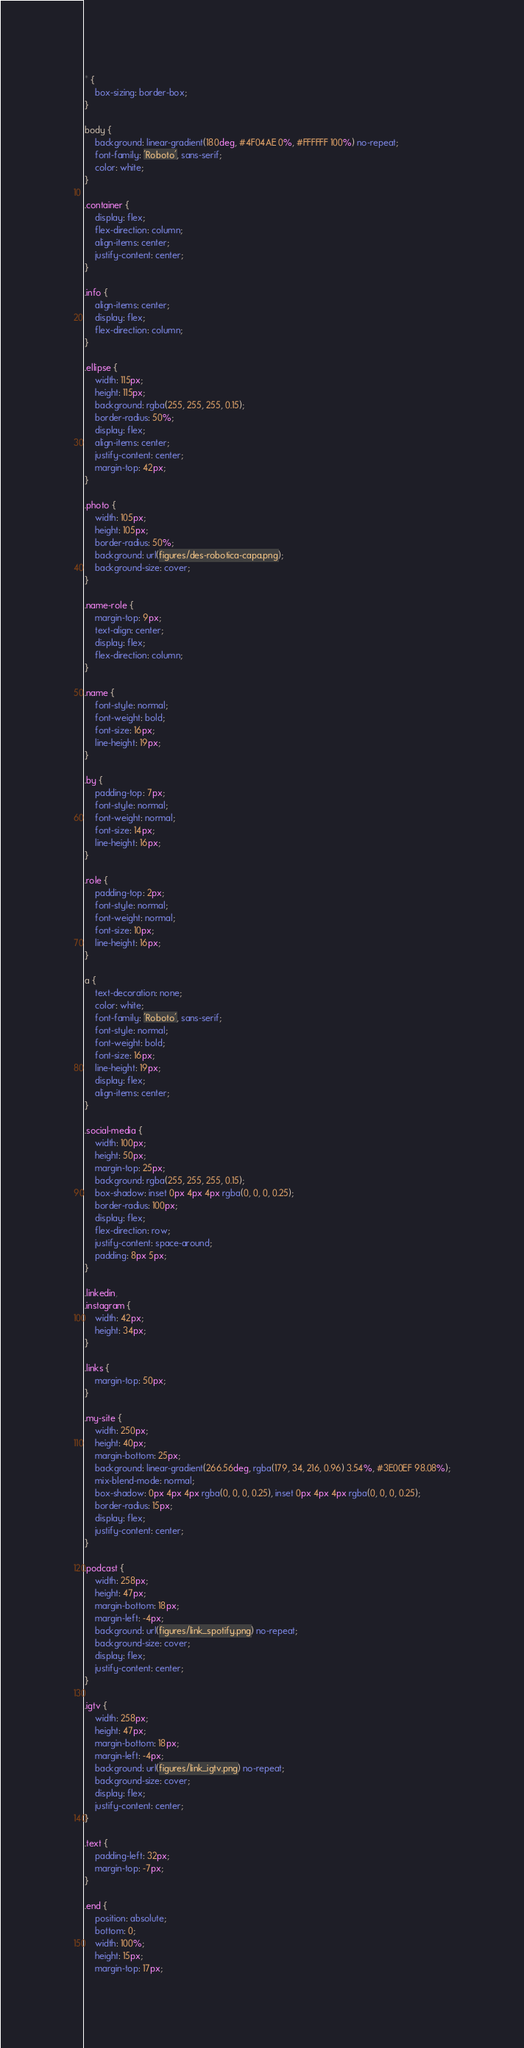<code> <loc_0><loc_0><loc_500><loc_500><_CSS_>* {
    box-sizing: border-box;
}

body {
    background: linear-gradient(180deg, #4F04AE 0%, #FFFFFF 100%) no-repeat;
    font-family: 'Roboto', sans-serif;
    color: white;
}

.container {
    display: flex;
    flex-direction: column;
    align-items: center;
    justify-content: center;
}

.info {
    align-items: center;
    display: flex;
    flex-direction: column;
}

.ellipse {
    width: 115px;
    height: 115px;
    background: rgba(255, 255, 255, 0.15);
    border-radius: 50%;
    display: flex;
    align-items: center;
    justify-content: center;
    margin-top: 42px;
}

.photo {
    width: 105px;
    height: 105px;
    border-radius: 50%;
    background: url(figures/des-robotica-capa.png);
    background-size: cover;
}

.name-role {
    margin-top: 9px;
    text-align: center;
    display: flex;
    flex-direction: column;
}

.name {
    font-style: normal;
    font-weight: bold;
    font-size: 16px;
    line-height: 19px;
}

.by {
    padding-top: 7px;
    font-style: normal;
    font-weight: normal;
    font-size: 14px;
    line-height: 16px;
}

.role {
    padding-top: 2px;
    font-style: normal;
    font-weight: normal;
    font-size: 10px;
    line-height: 16px;
}

a {
    text-decoration: none;
    color: white;
    font-family: 'Roboto', sans-serif;
    font-style: normal;
    font-weight: bold;
    font-size: 16px;
    line-height: 19px;
    display: flex;
    align-items: center;
}

.social-media {
    width: 100px;
    height: 50px;
    margin-top: 25px;
    background: rgba(255, 255, 255, 0.15);
    box-shadow: inset 0px 4px 4px rgba(0, 0, 0, 0.25);
    border-radius: 100px;
    display: flex;
    flex-direction: row;
    justify-content: space-around;
    padding: 8px 5px;
}

.linkedin,
.instagram {
    width: 42px;
    height: 34px;
}

.links {
    margin-top: 50px;
}

.my-site {
    width: 250px;
    height: 40px;
    margin-bottom: 25px;
    background: linear-gradient(266.56deg, rgba(179, 34, 216, 0.96) 3.54%, #3E00EF 98.08%);
    mix-blend-mode: normal;
    box-shadow: 0px 4px 4px rgba(0, 0, 0, 0.25), inset 0px 4px 4px rgba(0, 0, 0, 0.25);
    border-radius: 15px;
    display: flex;
    justify-content: center;
}

.podcast {
    width: 258px;
    height: 47px;
    margin-bottom: 18px;
    margin-left: -4px;
    background: url(figures/link_spotify.png) no-repeat;
    background-size: cover;
    display: flex;
    justify-content: center;
}

.igtv {
    width: 258px;
    height: 47px;
    margin-bottom: 18px;
    margin-left: -4px;
    background: url(figures/link_igtv.png) no-repeat;
    background-size: cover;
    display: flex;
    justify-content: center;
}

.text {
    padding-left: 32px;
    margin-top: -7px;
}

.end {
    position: absolute;
    bottom: 0;
    width: 100%;
    height: 15px;
    margin-top: 17px;</code> 